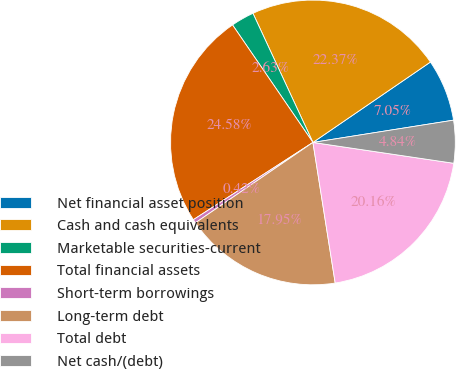Convert chart. <chart><loc_0><loc_0><loc_500><loc_500><pie_chart><fcel>Net financial asset position<fcel>Cash and cash equivalents<fcel>Marketable securities-current<fcel>Total financial assets<fcel>Short-term borrowings<fcel>Long-term debt<fcel>Total debt<fcel>Net cash/(debt)<nl><fcel>7.05%<fcel>22.37%<fcel>2.63%<fcel>24.58%<fcel>0.42%<fcel>17.95%<fcel>20.16%<fcel>4.84%<nl></chart> 